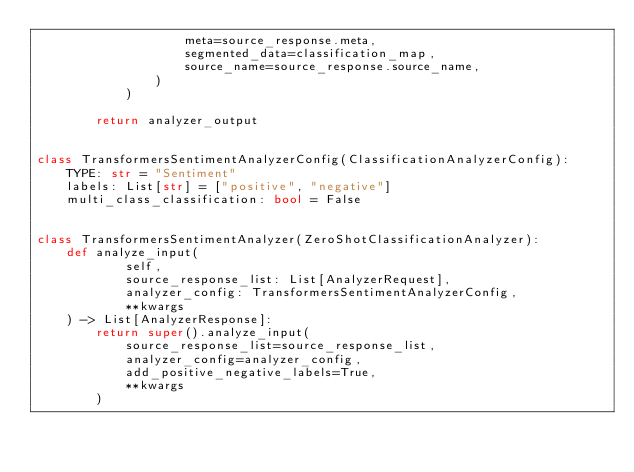<code> <loc_0><loc_0><loc_500><loc_500><_Python_>                    meta=source_response.meta,
                    segmented_data=classification_map,
                    source_name=source_response.source_name,
                )
            )

        return analyzer_output


class TransformersSentimentAnalyzerConfig(ClassificationAnalyzerConfig):
    TYPE: str = "Sentiment"
    labels: List[str] = ["positive", "negative"]
    multi_class_classification: bool = False


class TransformersSentimentAnalyzer(ZeroShotClassificationAnalyzer):
    def analyze_input(
            self,
            source_response_list: List[AnalyzerRequest],
            analyzer_config: TransformersSentimentAnalyzerConfig,
            **kwargs
    ) -> List[AnalyzerResponse]:
        return super().analyze_input(
            source_response_list=source_response_list,
            analyzer_config=analyzer_config,
            add_positive_negative_labels=True,
            **kwargs
        )
</code> 